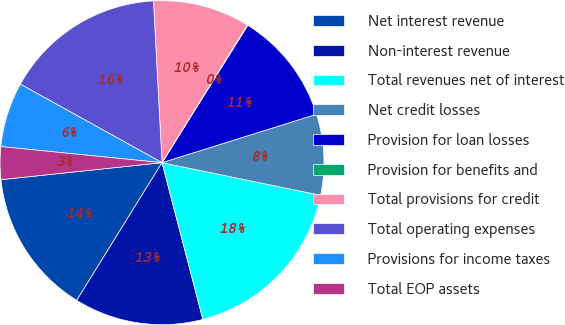Convert chart to OTSL. <chart><loc_0><loc_0><loc_500><loc_500><pie_chart><fcel>Net interest revenue<fcel>Non-interest revenue<fcel>Total revenues net of interest<fcel>Net credit losses<fcel>Provision for loan losses<fcel>Provision for benefits and<fcel>Total provisions for credit<fcel>Total operating expenses<fcel>Provisions for income taxes<fcel>Total EOP assets<nl><fcel>14.5%<fcel>12.89%<fcel>17.71%<fcel>8.07%<fcel>11.28%<fcel>0.05%<fcel>9.68%<fcel>16.1%<fcel>6.47%<fcel>3.26%<nl></chart> 